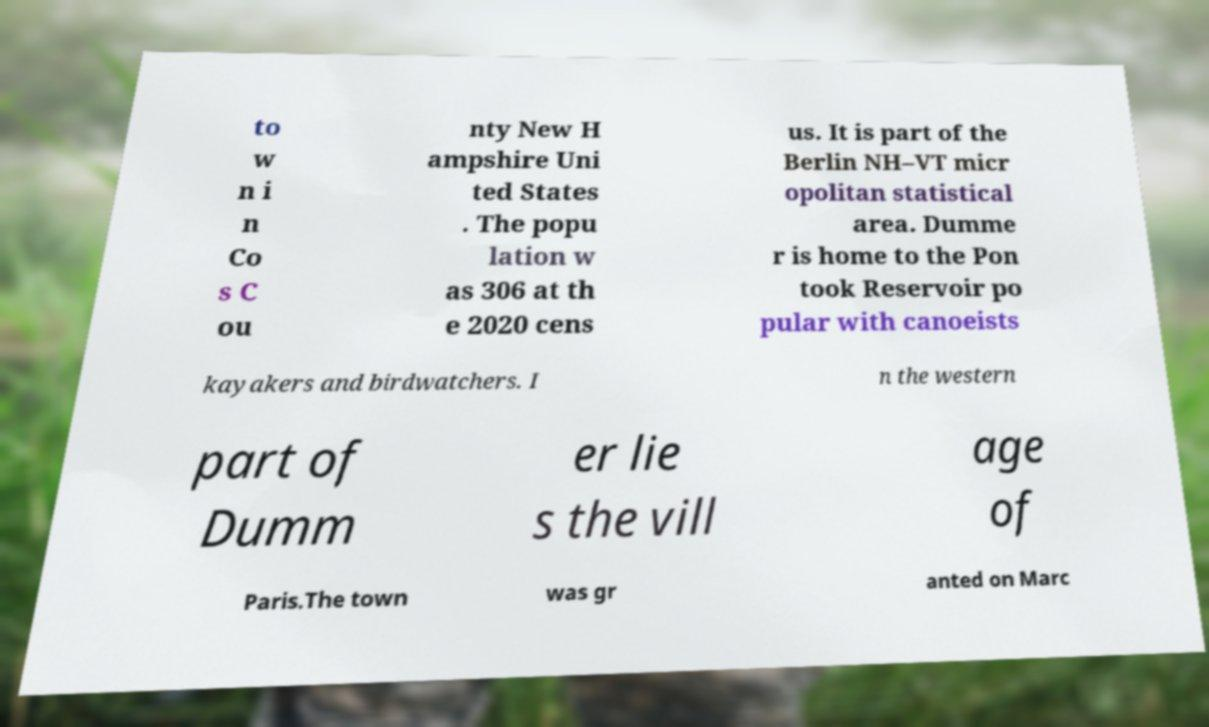Can you accurately transcribe the text from the provided image for me? to w n i n Co s C ou nty New H ampshire Uni ted States . The popu lation w as 306 at th e 2020 cens us. It is part of the Berlin NH–VT micr opolitan statistical area. Dumme r is home to the Pon took Reservoir po pular with canoeists kayakers and birdwatchers. I n the western part of Dumm er lie s the vill age of Paris.The town was gr anted on Marc 